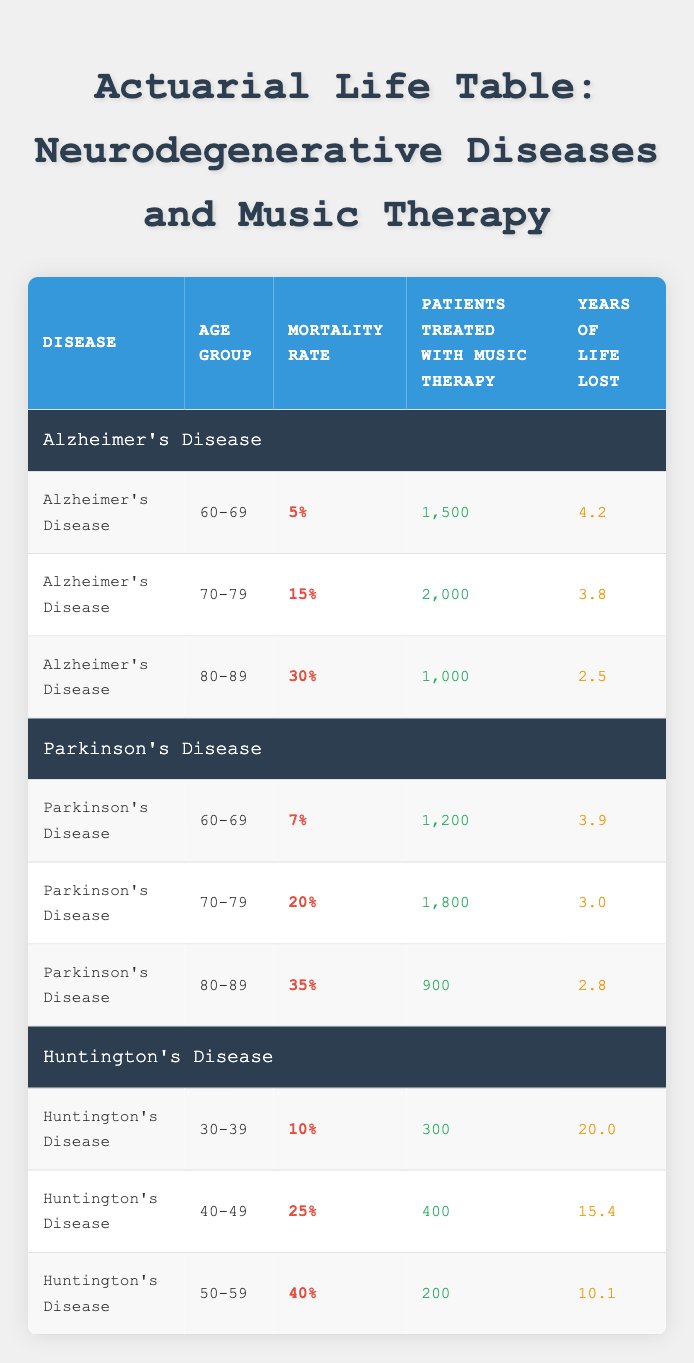What is the mortality rate for Alzheimer's Disease in the age group 70-79? The table specifically lists the mortality rate for Alzheimer's Disease in the 70-79 age group as 15%. This information can be found directly in the corresponding row of the table.
Answer: 15% How many patients with Parkinson's Disease were treated with music therapy in the age group 60-69? According to the table, there are 1,200 patients treated with music therapy for Parkinson's Disease in the 60-69 age group. This figure is presented clearly under the "Patients Treated with Music Therapy" column.
Answer: 1,200 What is the total number of patients treated with music therapy for Huntington's Disease across all age groups? To find the total patients treated for Huntington's Disease, we add the numbers of patients from each age group: 300 (30-39) + 400 (40-49) + 200 (50-59) = 900. Therefore, the total is 900.
Answer: 900 Is the mortality rate for Parkinson's Disease higher in the 80-89 age group compared to the 70-79 age group? The table shows the mortality rate for Parkinson's Disease as 35% for the 80-89 age group and 20% for the 70-79 age group. Since 35% is greater than 20%, we can conclude that the statement is true.
Answer: Yes What is the average number of years of life lost for patients treated with music therapy for Huntington's Disease? The years of life lost for Huntington's Disease patients are 20.0 (30-39), 15.4 (40-49), and 10.1 (50-59). We calculate the average by summing these values: 20.0 + 15.4 + 10.1 = 45.5. Dividing by the number of age groups (3) gives us an average of 45.5/3 = 15.17 years.
Answer: 15.17 Which neurodegenerative disease has the highest reported mortality rate in the 80-89 age group? For the 80-89 age group, Alzheimer's Disease has a mortality rate of 30%, while Parkinson's Disease has a rate of 35%. Comparing these two, we see that Parkinson's Disease has a higher mortality rate in this age group.
Answer: Parkinson's Disease What is the percentage difference in mortality rates between the 60-69 age group and the 70-79 age group for Alzheimer's Disease? The mortality rate for Alzheimer's Disease is 5% in the 60-69 age group and 15% in the 70-79 age group. The percentage difference can be calculated as: (15% - 5%) / 5% * 100% = 200%.
Answer: 200% Are there more patients treated with music therapy for Alzheimer's Disease than for Huntington's Disease in the 50-59 age group? For Alzheimer's Disease in the 50-59 age group, there are no listed patients; meanwhile, for Huntington's Disease, there are 200 patients. Therefore, the statement is true since 0 is less than 200.
Answer: Yes 